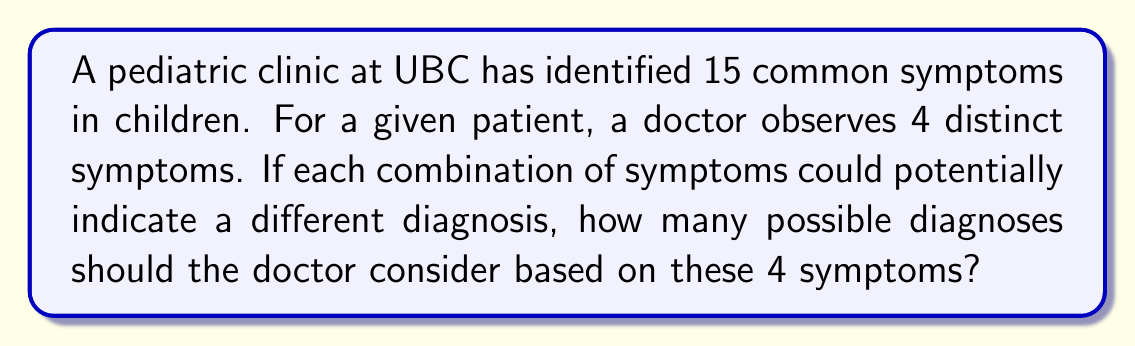Can you solve this math problem? Let's approach this step-by-step:

1) This is a combination problem. We need to calculate the number of ways to choose 4 symptoms out of 15.

2) The order of symptoms doesn't matter (e.g., fever + cough is the same as cough + fever), so we use combinations rather than permutations.

3) The formula for combinations is:

   $$C(n,r) = \frac{n!}{r!(n-r)!}$$

   Where $n$ is the total number of items to choose from, and $r$ is the number of items being chosen.

4) In this case, $n = 15$ (total symptoms) and $r = 4$ (observed symptoms).

5) Plugging these numbers into the formula:

   $$C(15,4) = \frac{15!}{4!(15-4)!} = \frac{15!}{4!11!}$$

6) Expanding this:
   
   $$\frac{15 \times 14 \times 13 \times 12 \times 11!}{(4 \times 3 \times 2 \times 1) \times 11!}$$

7) The 11! cancels out in the numerator and denominator:

   $$\frac{15 \times 14 \times 13 \times 12}{4 \times 3 \times 2 \times 1} = \frac{32760}{24} = 1365$$

Therefore, there are 1365 possible combinations of 4 symptoms from a set of 15 symptoms, each potentially indicating a different diagnosis.
Answer: 1365 possible diagnoses 